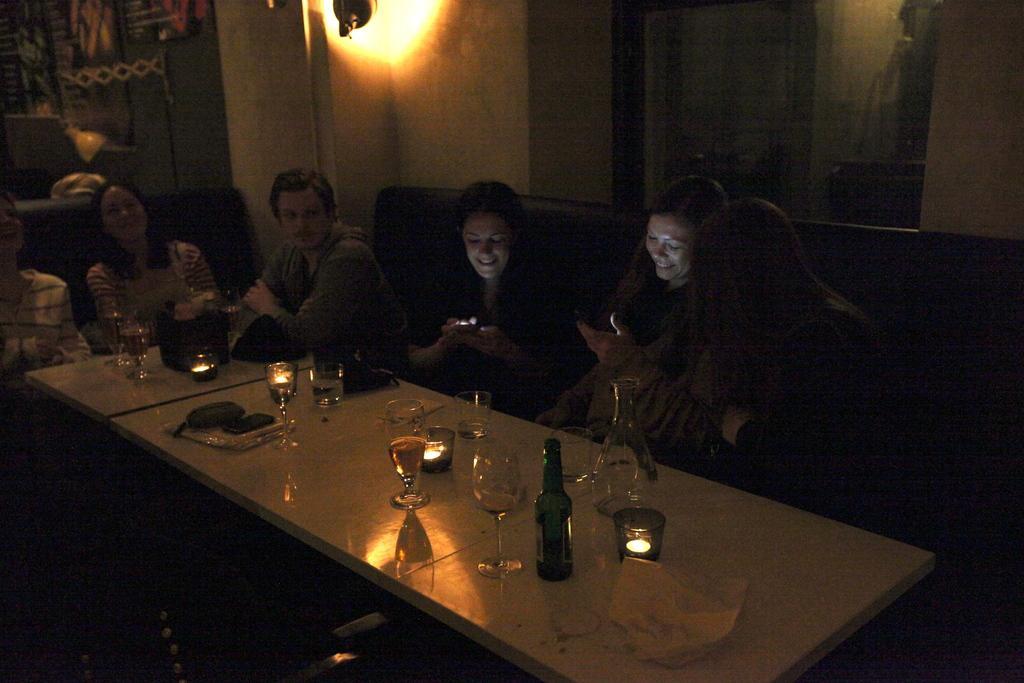Could you give a brief overview of what you see in this image? This picture is of inside the room. In the center on there is a table on the top of which glasses containing drinks and bottles are placed. There are group of persons sitting on the sofas. In the background we can see a wall, wall lamp and wall poster. 